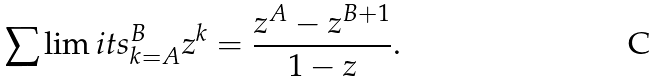Convert formula to latex. <formula><loc_0><loc_0><loc_500><loc_500>\sum \lim i t s _ { k = A } ^ { B } z ^ { k } = \frac { z ^ { A } - z ^ { B + 1 } } { 1 - z } .</formula> 